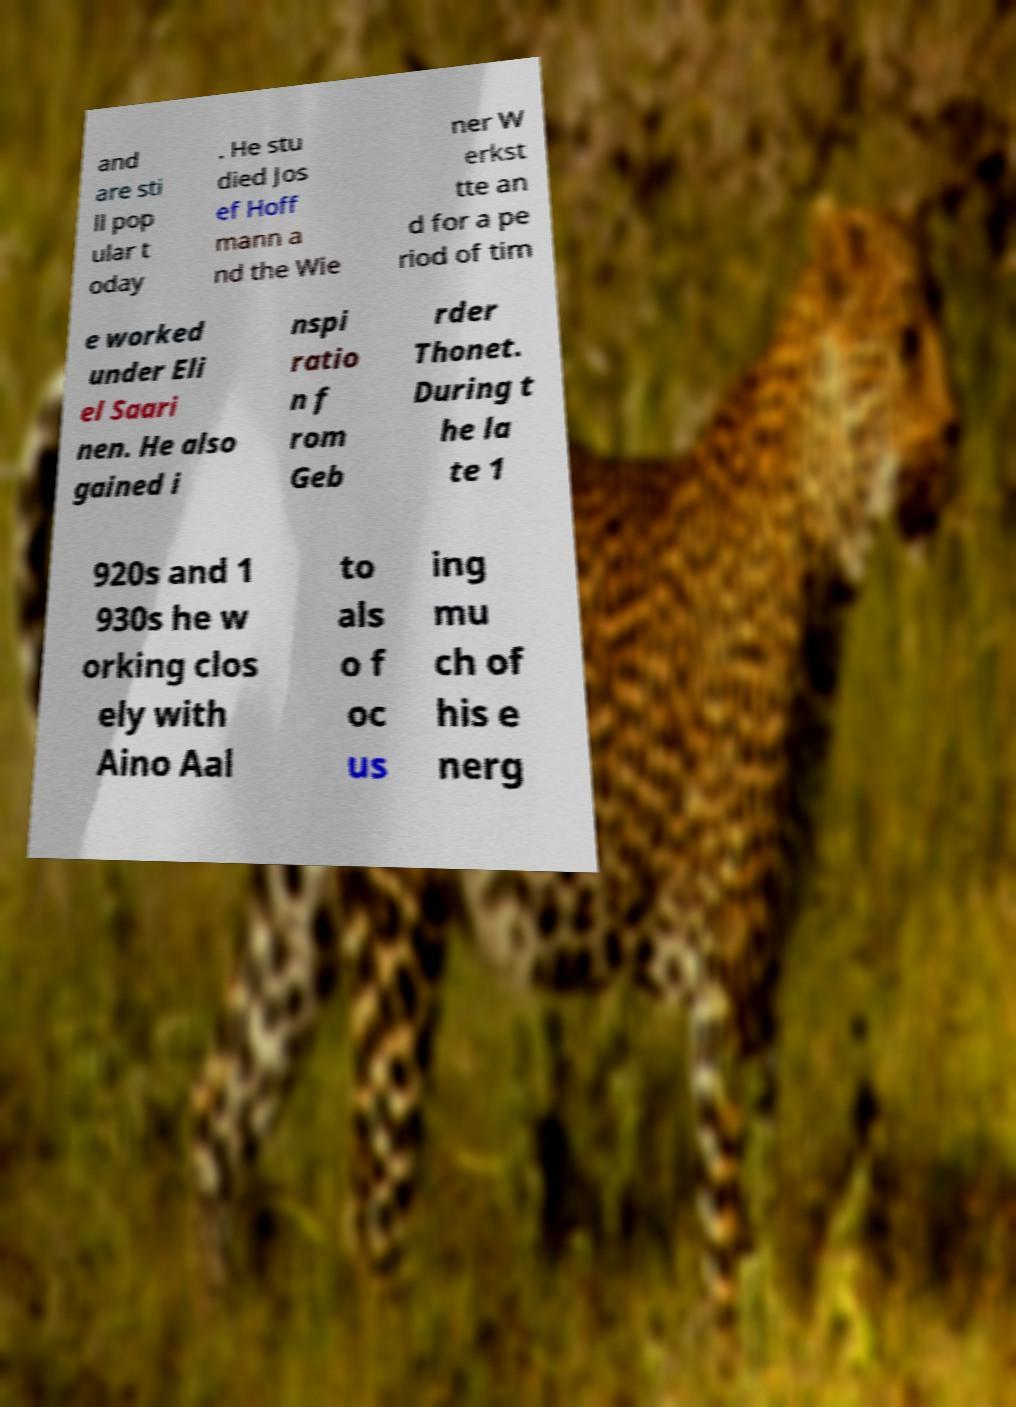Could you assist in decoding the text presented in this image and type it out clearly? and are sti ll pop ular t oday . He stu died Jos ef Hoff mann a nd the Wie ner W erkst tte an d for a pe riod of tim e worked under Eli el Saari nen. He also gained i nspi ratio n f rom Geb rder Thonet. During t he la te 1 920s and 1 930s he w orking clos ely with Aino Aal to als o f oc us ing mu ch of his e nerg 